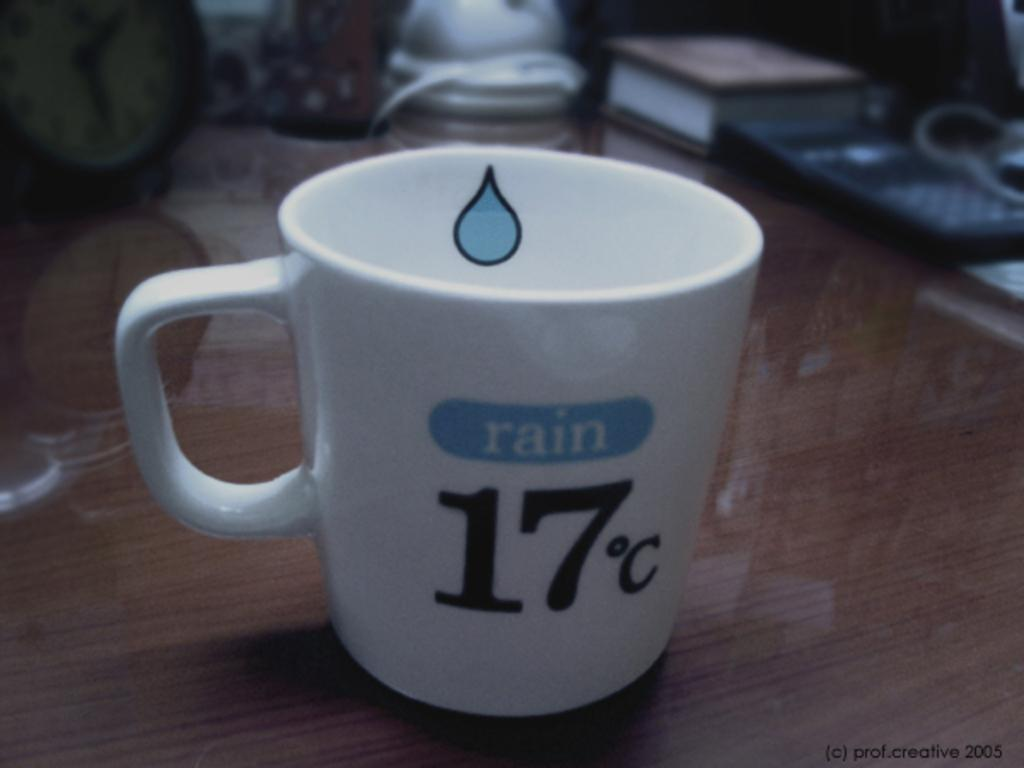<image>
Give a short and clear explanation of the subsequent image. A white teacup that has a blue raindrop on the inside, the word rain in blue and 17 degrees c on the front logo. 